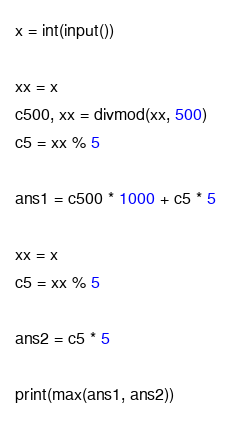Convert code to text. <code><loc_0><loc_0><loc_500><loc_500><_Python_>x = int(input())

xx = x
c500, xx = divmod(xx, 500)
c5 = xx % 5

ans1 = c500 * 1000 + c5 * 5

xx = x
c5 = xx % 5

ans2 = c5 * 5

print(max(ans1, ans2))</code> 